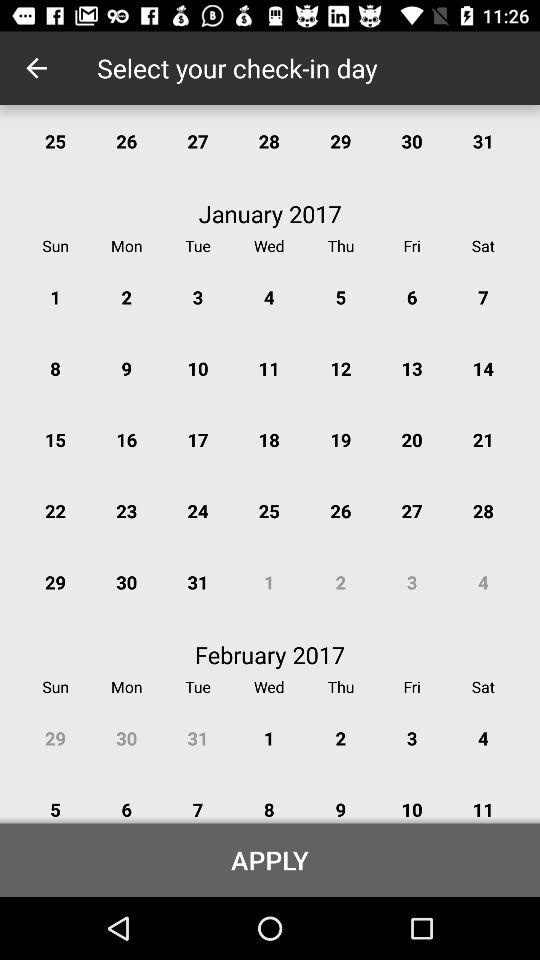What year is shown on the calendar? The year is "2017". 